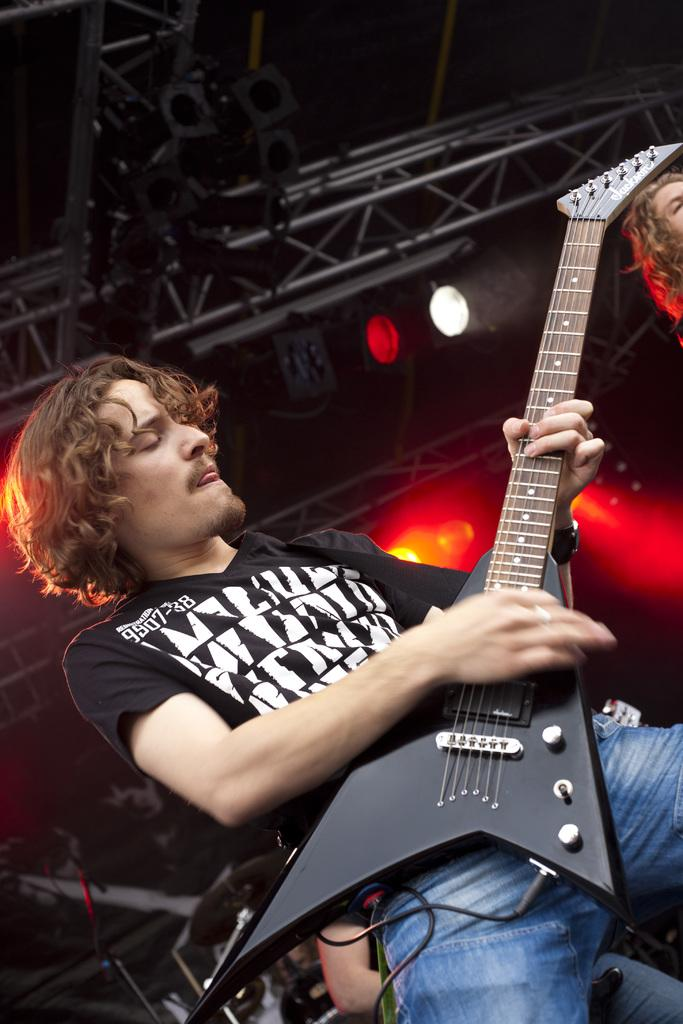What is the man in the image doing? The man is standing and playing a guitar in the image. Can you describe anything else about the man in the image? There is no additional information about the man provided in the facts. What can be seen in the right corner of the image? There is a woman's face visible in the right corner of the image. What type of lighting is present at the top of the image? Show lights are present at the top of the image. What type of snakes are used as props in the image? There are no snakes present in the image. What religious belief does the man in the image follow? There is no information about the man's religious beliefs provided in the facts. 